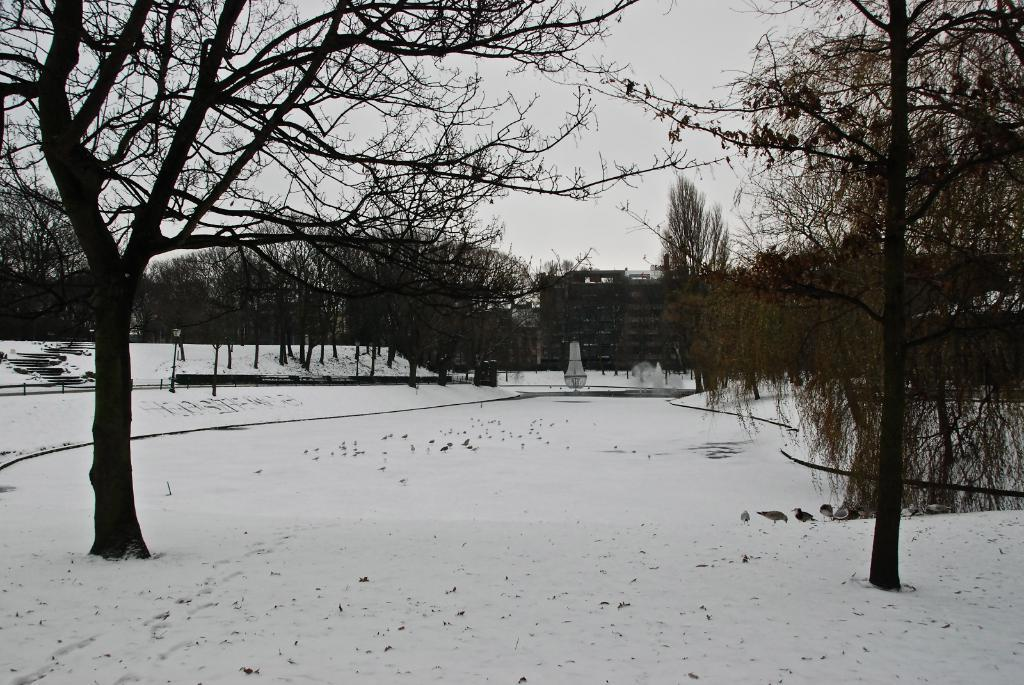What type of animals can be seen in the image? There are birds on snow in the image. What natural elements are present in the image? There are trees in the image. What man-made structure is visible in the image? There is a building in the image. What can be seen in the background of the image? The sky is visible in the background of the image. What type of zipper can be seen on the birds in the image? There are no zippers present on the birds in the image. What message is being conveyed by the birds in the image as they say good-bye? The birds in the image are not conveying any message or saying good-bye, as they are simply standing on the snow. 